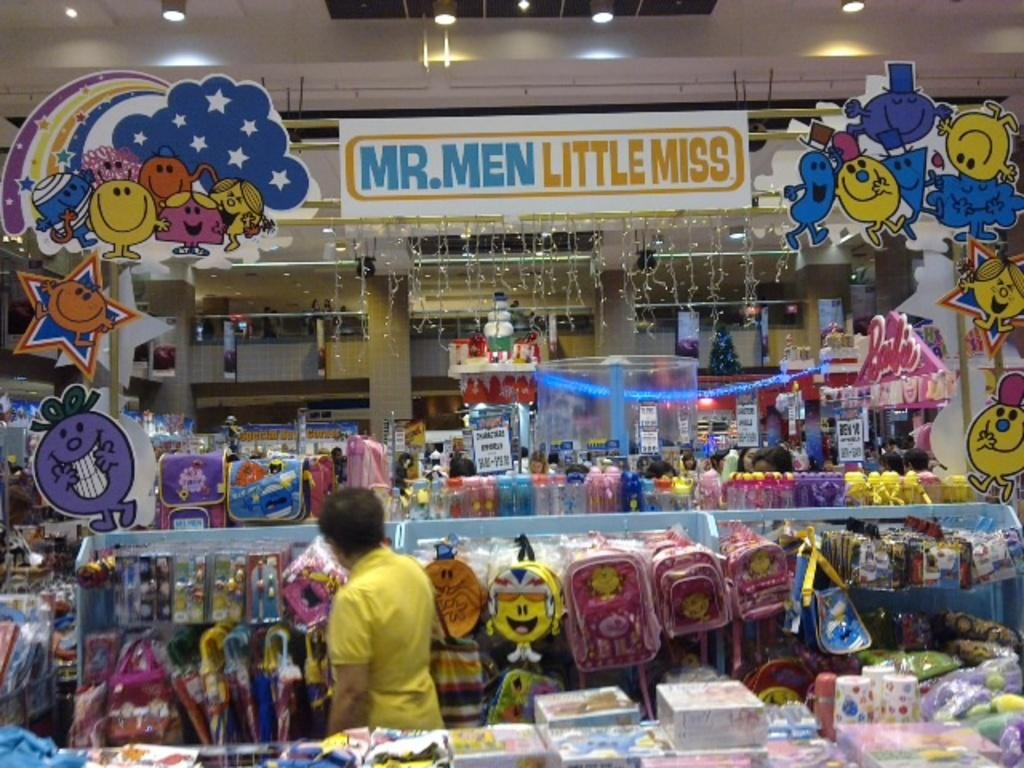<image>
Offer a succinct explanation of the picture presented. The sign hanging in the clothes store is for mr. men and little miss 